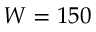<formula> <loc_0><loc_0><loc_500><loc_500>W = 1 5 0</formula> 